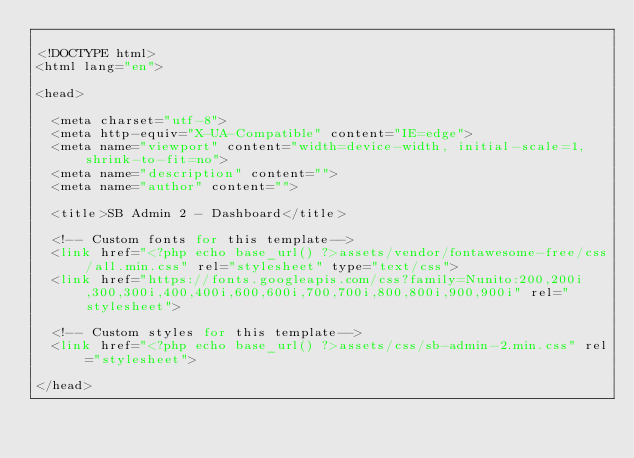<code> <loc_0><loc_0><loc_500><loc_500><_PHP_>
<!DOCTYPE html>
<html lang="en">

<head>

  <meta charset="utf-8">
  <meta http-equiv="X-UA-Compatible" content="IE=edge">
  <meta name="viewport" content="width=device-width, initial-scale=1, shrink-to-fit=no">
  <meta name="description" content="">
  <meta name="author" content="">

  <title>SB Admin 2 - Dashboard</title>

  <!-- Custom fonts for this template-->
  <link href="<?php echo base_url() ?>assets/vendor/fontawesome-free/css/all.min.css" rel="stylesheet" type="text/css">
  <link href="https://fonts.googleapis.com/css?family=Nunito:200,200i,300,300i,400,400i,600,600i,700,700i,800,800i,900,900i" rel="stylesheet">

  <!-- Custom styles for this template-->
  <link href="<?php echo base_url() ?>assets/css/sb-admin-2.min.css" rel="stylesheet">

</head>
</code> 